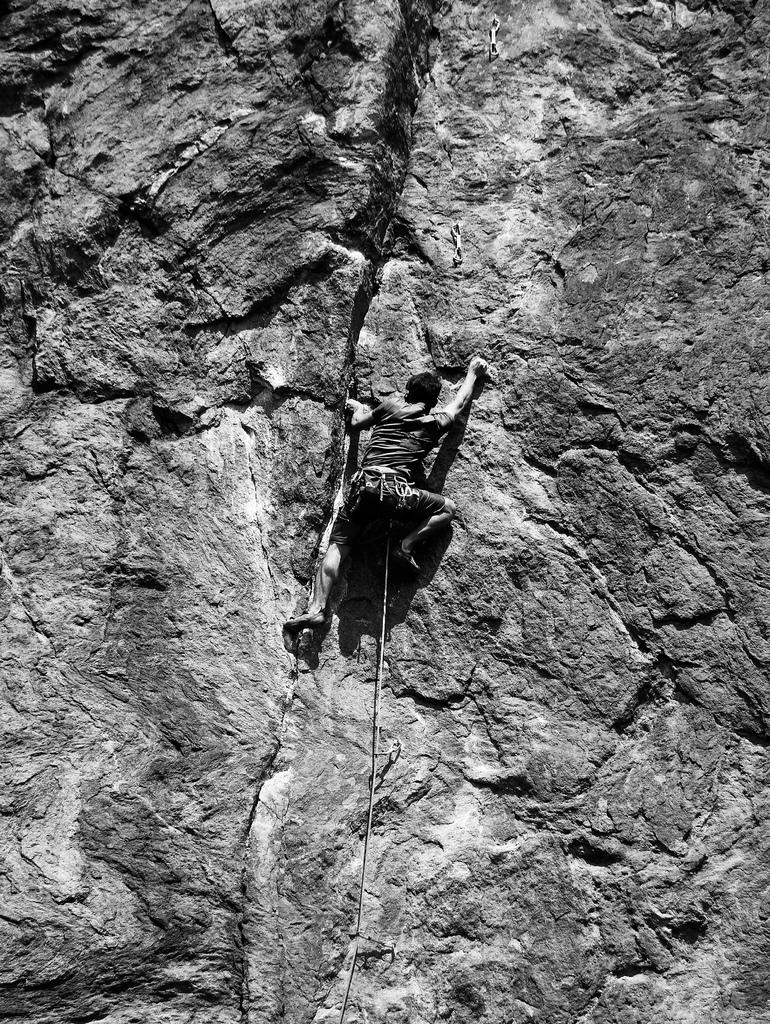What is the color scheme of the image? The image is black and white. Can you describe the main subject of the image? There is a person in the image. What is the person doing in the image? The person is climbing a mountain. What type of jam is being spread on the coast in the image? There is no jam or coast present in the image; it features a person climbing a mountain in a black and white setting. 